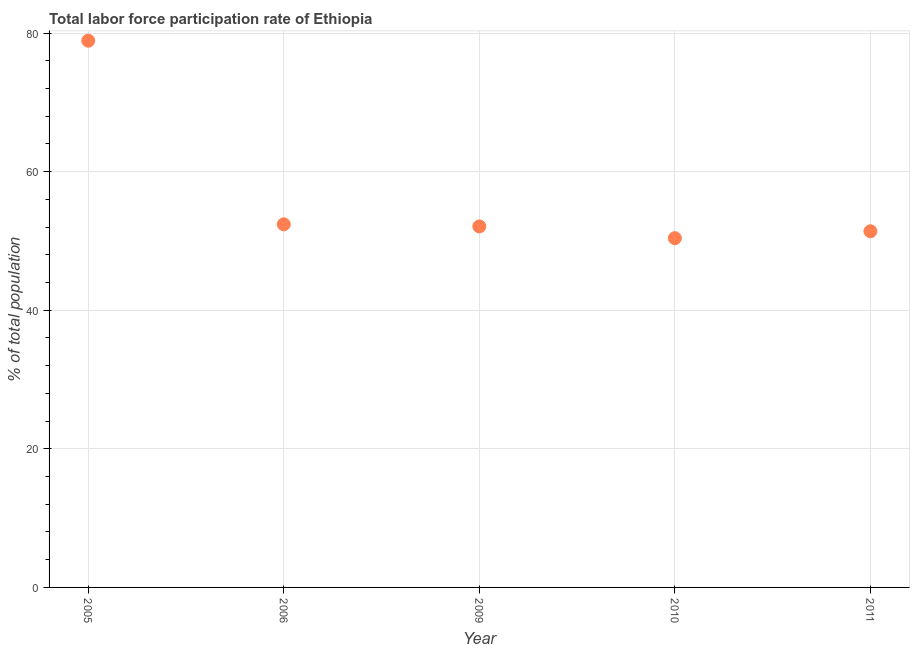What is the total labor force participation rate in 2009?
Give a very brief answer. 52.1. Across all years, what is the maximum total labor force participation rate?
Offer a very short reply. 78.9. Across all years, what is the minimum total labor force participation rate?
Ensure brevity in your answer.  50.4. What is the sum of the total labor force participation rate?
Ensure brevity in your answer.  285.2. What is the difference between the total labor force participation rate in 2005 and 2009?
Provide a short and direct response. 26.8. What is the average total labor force participation rate per year?
Offer a terse response. 57.04. What is the median total labor force participation rate?
Offer a very short reply. 52.1. What is the ratio of the total labor force participation rate in 2005 to that in 2011?
Your answer should be compact. 1.54. Is the total labor force participation rate in 2005 less than that in 2009?
Provide a succinct answer. No. Is the difference between the total labor force participation rate in 2005 and 2010 greater than the difference between any two years?
Your answer should be very brief. Yes. What is the difference between the highest and the second highest total labor force participation rate?
Give a very brief answer. 26.5. Is the sum of the total labor force participation rate in 2006 and 2010 greater than the maximum total labor force participation rate across all years?
Provide a short and direct response. Yes. What is the difference between the highest and the lowest total labor force participation rate?
Offer a very short reply. 28.5. Does the total labor force participation rate monotonically increase over the years?
Your response must be concise. No. How many dotlines are there?
Your answer should be very brief. 1. How many years are there in the graph?
Your response must be concise. 5. Are the values on the major ticks of Y-axis written in scientific E-notation?
Offer a very short reply. No. Does the graph contain grids?
Ensure brevity in your answer.  Yes. What is the title of the graph?
Provide a succinct answer. Total labor force participation rate of Ethiopia. What is the label or title of the X-axis?
Keep it short and to the point. Year. What is the label or title of the Y-axis?
Offer a terse response. % of total population. What is the % of total population in 2005?
Keep it short and to the point. 78.9. What is the % of total population in 2006?
Keep it short and to the point. 52.4. What is the % of total population in 2009?
Your response must be concise. 52.1. What is the % of total population in 2010?
Make the answer very short. 50.4. What is the % of total population in 2011?
Your response must be concise. 51.4. What is the difference between the % of total population in 2005 and 2006?
Ensure brevity in your answer.  26.5. What is the difference between the % of total population in 2005 and 2009?
Ensure brevity in your answer.  26.8. What is the difference between the % of total population in 2005 and 2011?
Provide a succinct answer. 27.5. What is the difference between the % of total population in 2009 and 2010?
Keep it short and to the point. 1.7. What is the difference between the % of total population in 2010 and 2011?
Ensure brevity in your answer.  -1. What is the ratio of the % of total population in 2005 to that in 2006?
Give a very brief answer. 1.51. What is the ratio of the % of total population in 2005 to that in 2009?
Make the answer very short. 1.51. What is the ratio of the % of total population in 2005 to that in 2010?
Keep it short and to the point. 1.56. What is the ratio of the % of total population in 2005 to that in 2011?
Keep it short and to the point. 1.53. What is the ratio of the % of total population in 2006 to that in 2010?
Ensure brevity in your answer.  1.04. What is the ratio of the % of total population in 2006 to that in 2011?
Provide a succinct answer. 1.02. What is the ratio of the % of total population in 2009 to that in 2010?
Provide a short and direct response. 1.03. What is the ratio of the % of total population in 2009 to that in 2011?
Give a very brief answer. 1.01. What is the ratio of the % of total population in 2010 to that in 2011?
Keep it short and to the point. 0.98. 